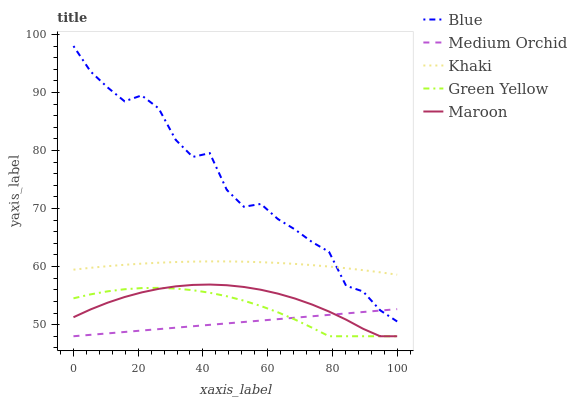Does Green Yellow have the minimum area under the curve?
Answer yes or no. No. Does Green Yellow have the maximum area under the curve?
Answer yes or no. No. Is Green Yellow the smoothest?
Answer yes or no. No. Is Green Yellow the roughest?
Answer yes or no. No. Does Khaki have the lowest value?
Answer yes or no. No. Does Green Yellow have the highest value?
Answer yes or no. No. Is Medium Orchid less than Khaki?
Answer yes or no. Yes. Is Khaki greater than Maroon?
Answer yes or no. Yes. Does Medium Orchid intersect Khaki?
Answer yes or no. No. 